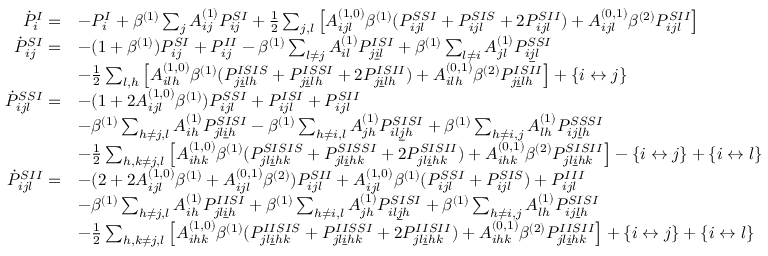Convert formula to latex. <formula><loc_0><loc_0><loc_500><loc_500>\begin{array} { r l } { \dot { P } _ { i } ^ { I } = } & { - P _ { i } ^ { I } + \beta ^ { ( 1 ) } \sum _ { j } A _ { i j } ^ { ( 1 ) } P _ { i j } ^ { S I } + \frac { 1 } { 2 } \sum _ { j , l } \left [ A _ { i j l } ^ { ( 1 , 0 ) } \beta ^ { ( 1 ) } ( P _ { i j l } ^ { S S I } + P _ { i j l } ^ { S I S } + 2 P _ { i j l } ^ { S I I } ) + A _ { i j l } ^ { ( 0 , 1 ) } \beta ^ { ( 2 ) } P _ { i j l } ^ { S I I } \right ] } \\ { \dot { P } _ { i j } ^ { S I } = } & { - ( 1 + \beta ^ { ( 1 ) } ) P _ { i j } ^ { S I } + P _ { i j } ^ { I I } - \beta ^ { ( 1 ) } \sum _ { l \neq j } A _ { i l } ^ { ( 1 ) } P _ { j \underline { i } l } ^ { I S I } + \beta ^ { ( 1 ) } \sum _ { l \neq i } A _ { j l } ^ { ( 1 ) } P _ { i \underline { j } l } ^ { S S I } } \\ & { - \frac { 1 } { 2 } \sum _ { l , h } \left [ A _ { i l h } ^ { ( 1 , 0 ) } \beta ^ { ( 1 ) } ( P _ { j \underline { i } l h } ^ { I S I S } + P _ { j \underline { i } l h } ^ { I S S I } + 2 P _ { j \underline { i } l h } ^ { I S I I } ) + A _ { i l h } ^ { ( 0 , 1 ) } \beta ^ { ( 2 ) } P _ { j \underline { i } l h } ^ { I S I I } \right ] + \{ i \leftrightarrow j \} } \\ { \dot { P } _ { i j l } ^ { S S I } = } & { - ( 1 + 2 A _ { i j l } ^ { ( 1 , 0 ) } \beta ^ { ( 1 ) } ) P _ { i j l } ^ { S S I } + P _ { i j l } ^ { I S I } + P _ { i j l } ^ { S I I } } \\ & { - \beta ^ { ( 1 ) } \sum _ { h \neq j , l } A _ { i h } ^ { ( 1 ) } P _ { j l \underline { i } h } ^ { S I S I } - \beta ^ { ( 1 ) } \sum _ { h \neq i , l } A _ { j h } ^ { ( 1 ) } P _ { i l \underline { j } h } ^ { S I S I } + \beta ^ { ( 1 ) } \sum _ { h \neq i , j } A _ { l h } ^ { ( 1 ) } P _ { i j \underline { l } h } ^ { S S S I } } \\ & { - \frac { 1 } { 2 } \sum _ { h , k \neq j , l } \left [ A _ { i h k } ^ { ( 1 , 0 ) } \beta ^ { ( 1 ) } ( P _ { j l \underline { i } h k } ^ { S I S I S } + P _ { j l \underline { i } h k } ^ { S I S S I } + 2 P _ { j l \underline { i } h k } ^ { S I S I I } ) + A _ { i h k } ^ { ( 0 , 1 ) } \beta ^ { ( 2 ) } P _ { j l \underline { i } h k } ^ { S I S I I } \right ] - \{ i \leftrightarrow j \} + \{ i \leftrightarrow l \} } \\ { \dot { P } _ { i j l } ^ { S I I } = } & { - ( 2 + 2 A _ { i j l } ^ { ( 1 , 0 ) } \beta ^ { ( 1 ) } + A _ { i j l } ^ { ( 0 , 1 ) } \beta ^ { ( 2 ) } ) P _ { i j l } ^ { S I I } + A _ { i j l } ^ { ( 1 , 0 ) } \beta ^ { ( 1 ) } ( P _ { i j l } ^ { S S I } + P _ { i j l } ^ { S I S } ) + P _ { i j l } ^ { I I I } } \\ & { - \beta ^ { ( 1 ) } \sum _ { h \neq j , l } A _ { i h } ^ { ( 1 ) } P _ { j l \underline { i } h } ^ { I I S I } + \beta ^ { ( 1 ) } \sum _ { h \neq i , l } A _ { j h } ^ { ( 1 ) } P _ { i l \underline { j } h } ^ { S I S I } + \beta ^ { ( 1 ) } \sum _ { h \neq i , j } A _ { l h } ^ { ( 1 ) } P _ { i j \underline { l } h } ^ { S I S I } } \\ & { - \frac { 1 } { 2 } \sum _ { h , k \neq j , l } \left [ A _ { i h k } ^ { ( 1 , 0 ) } \beta ^ { ( 1 ) } ( P _ { j l \underline { i } h k } ^ { I I S I S } + P _ { j l \underline { i } h k } ^ { I I S S I } + 2 P _ { j l \underline { i } h k } ^ { I I S I I } ) + A _ { i h k } ^ { ( 0 , 1 ) } \beta ^ { ( 2 ) } P _ { j l \underline { i } h k } ^ { I I S I I } \right ] + \{ i \leftrightarrow j \} + \{ i \leftrightarrow l \} } \end{array}</formula> 